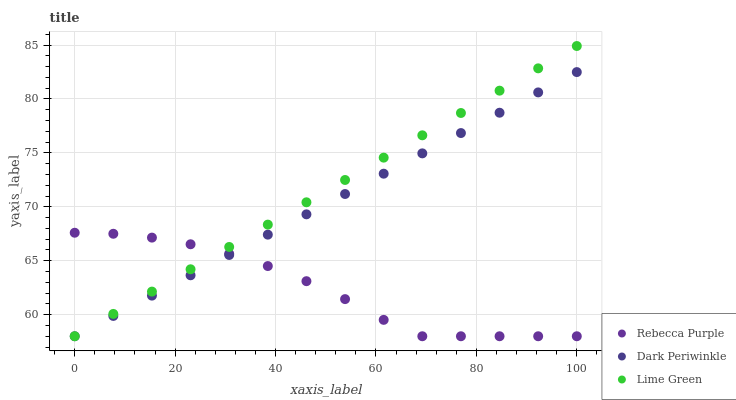Does Rebecca Purple have the minimum area under the curve?
Answer yes or no. Yes. Does Lime Green have the maximum area under the curve?
Answer yes or no. Yes. Does Dark Periwinkle have the minimum area under the curve?
Answer yes or no. No. Does Dark Periwinkle have the maximum area under the curve?
Answer yes or no. No. Is Dark Periwinkle the smoothest?
Answer yes or no. Yes. Is Rebecca Purple the roughest?
Answer yes or no. Yes. Is Rebecca Purple the smoothest?
Answer yes or no. No. Is Dark Periwinkle the roughest?
Answer yes or no. No. Does Lime Green have the lowest value?
Answer yes or no. Yes. Does Lime Green have the highest value?
Answer yes or no. Yes. Does Dark Periwinkle have the highest value?
Answer yes or no. No. Does Rebecca Purple intersect Dark Periwinkle?
Answer yes or no. Yes. Is Rebecca Purple less than Dark Periwinkle?
Answer yes or no. No. Is Rebecca Purple greater than Dark Periwinkle?
Answer yes or no. No. 